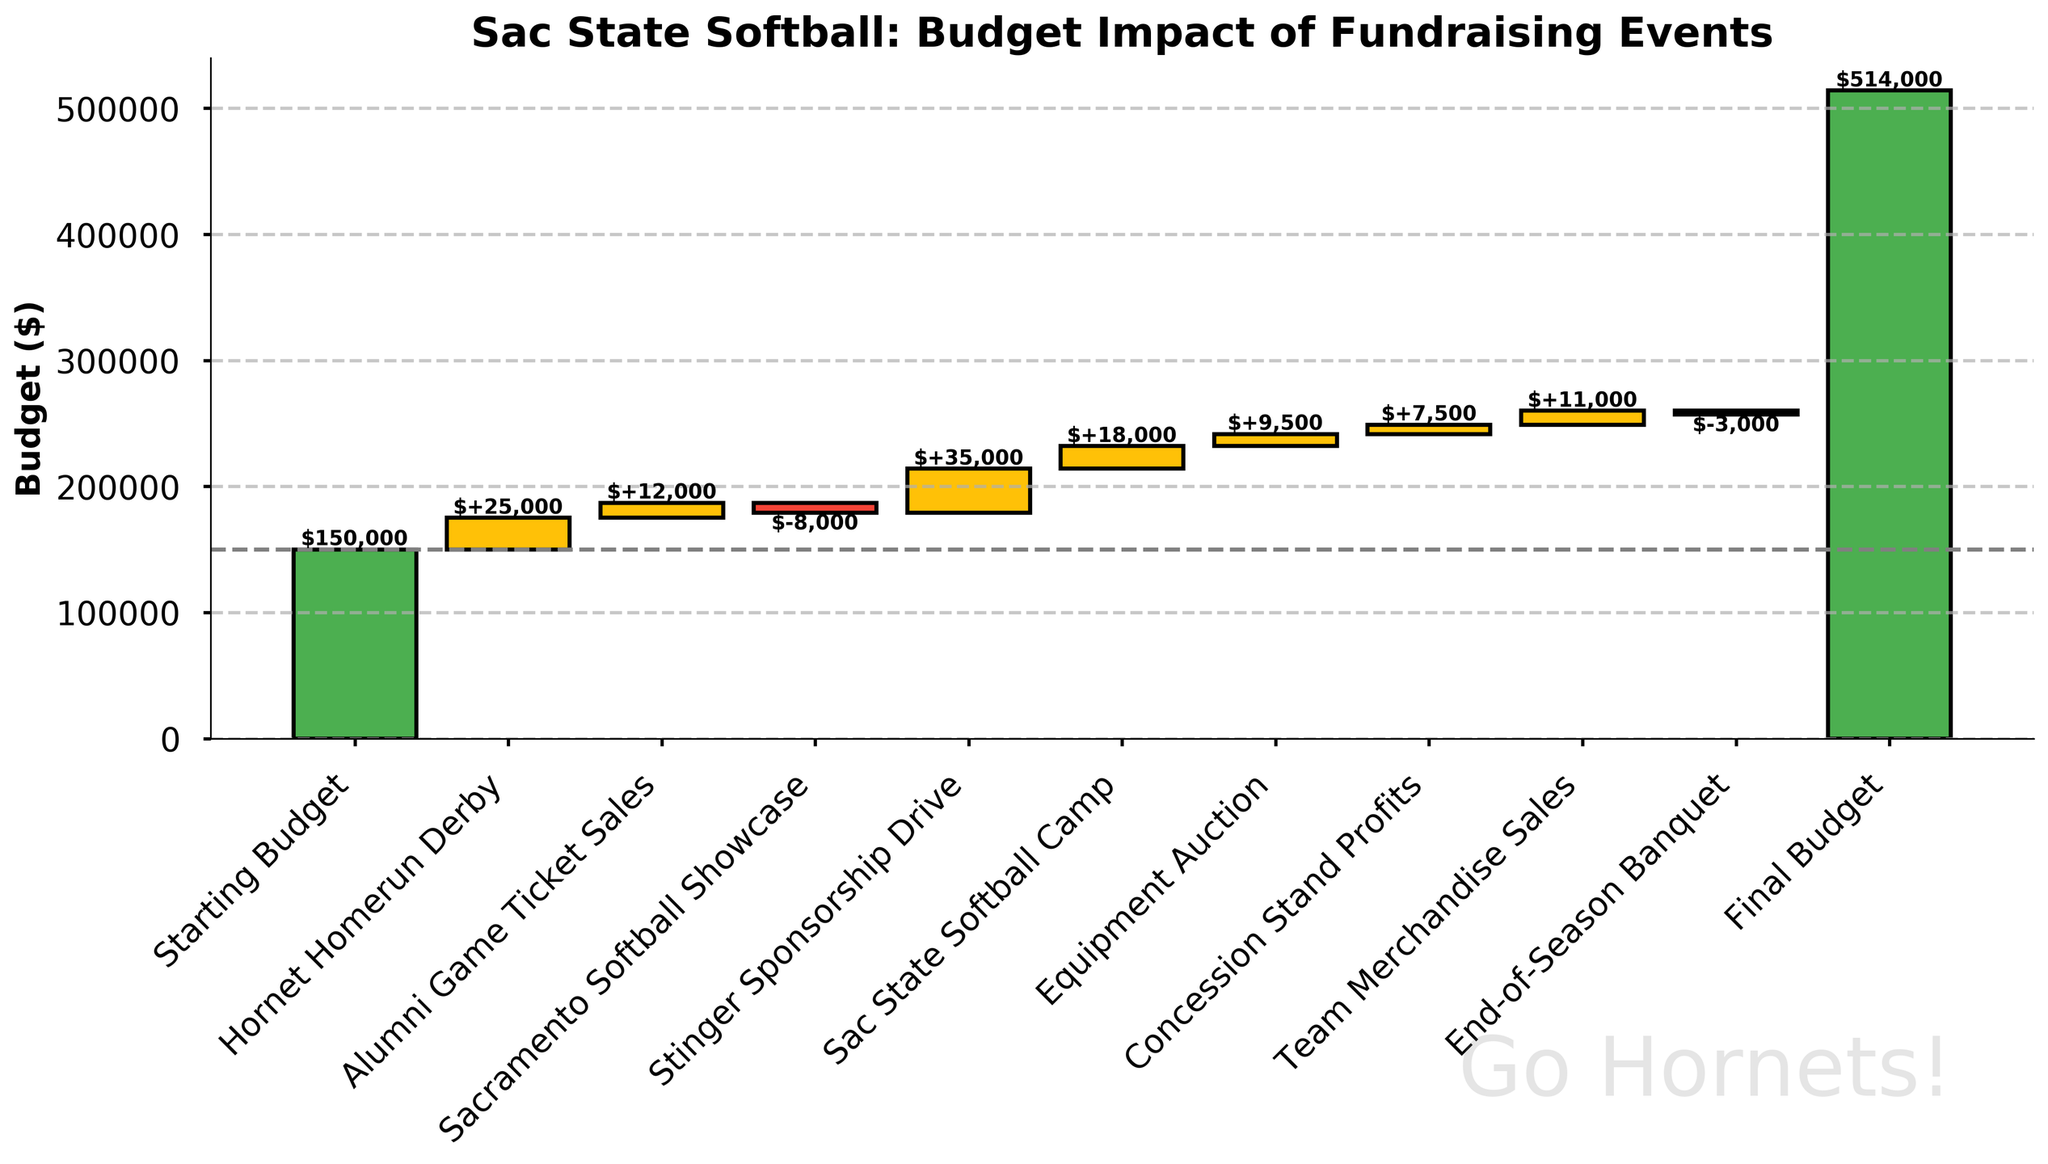How much was the starting budget? The starting budget is listed as the first event in the chart, labeled "Starting Budget." The value associated with it is $150,000.
Answer: $150,000 What is the title of the figure? The title of the figure is placed at the top of the chart and reads "Sac State Softball: Budget Impact of Fundraising Events."
Answer: Sac State Softball: Budget Impact of Fundraising Events Which fundraising event had the largest negative impact on the budget? The "Sacramento Softball Showcase" had the largest negative impact, as its bar goes downward significantly compared to the others.
Answer: Sacramento Softball Showcase What is the final budget after all the fundraising events? The final budget is listed as the last item in the chart, labeled "Final Budget." The value associated with it is $257,000.
Answer: $257,000 How much did the "Stinger Sponsorship Drive" contribute to the budget? The contribution from the "Stinger Sponsorship Drive" is represented by the height of the corresponding bar, which adds $35,000 to the budget.
Answer: $35,000 Compare the impacts of the "Equipment Auction" and "Concession Stand Profits" events. Which one had a greater impact? The heights of the bars for these events indicate their impacts. The "Equipment Auction" added $9,500, while "Concession Stand Profits" added $7,500, so the former had a greater impact.
Answer: Equipment Auction What is the total cumulative negative impact from "Sacramento Softball Showcase" and "End-of-Season Banquet"? The "Sacramento Softball Showcase" had a -$8,000 impact, and the "End-of-Season Banquet" had a -$3,000 impact. Adding these together gives a total cumulative negative impact of -$11,000.
Answer: -$11,000 What's the increase in the budget after both "Hornet Homerun Derby" and "Alumni Game Ticket Sales"? The "Hornet Homerun Derby" added $25,000, and the "Alumni Game Ticket Sales" added $12,000. The total increase is $25,000 + $12,000 = $37,000.
Answer: $37,000 How does the impact of "Team Merchandise Sales" compare to the initial budget? The "Team Merchandise Sales" contributed $11,000. This can be seen as an increase compared to the initial budget of $150,000.
Answer: $11,000 What is the cumulative budget after the "Sac State Softball Camp"? The "Sac State Softball Camp" added $18,000. Summing the impacts up to this point (starting budget, Hornet Homerun Derby, Alumni Game Ticket Sales, Sacramento Softball Showcase, Stinger Sponsorship Drive, and then Sac State Softball Camp) gives the cumulative budget.
Answer: $232,000 